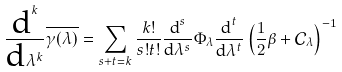<formula> <loc_0><loc_0><loc_500><loc_500>\frac { \text {d} ^ { k } } { \text {d} \lambda ^ { k } } \overline { \gamma ( \lambda ) } & = \sum _ { s + t = k } \frac { k ! } { s ! t ! } \frac { \text {d} ^ { s } } { \text {d} \lambda ^ { s } } \Phi _ { \lambda } \frac { \text {d} ^ { t } } { \text {d} \lambda ^ { t } } \left ( \frac { 1 } { 2 } \beta + \mathcal { C } _ { \lambda } \right ) ^ { - 1 }</formula> 